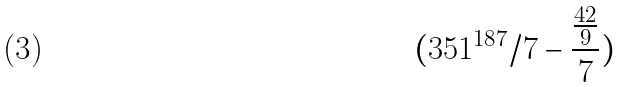Convert formula to latex. <formula><loc_0><loc_0><loc_500><loc_500>( 3 5 1 ^ { 1 8 7 } / 7 - \frac { \frac { 4 2 } { 9 } } { 7 } )</formula> 